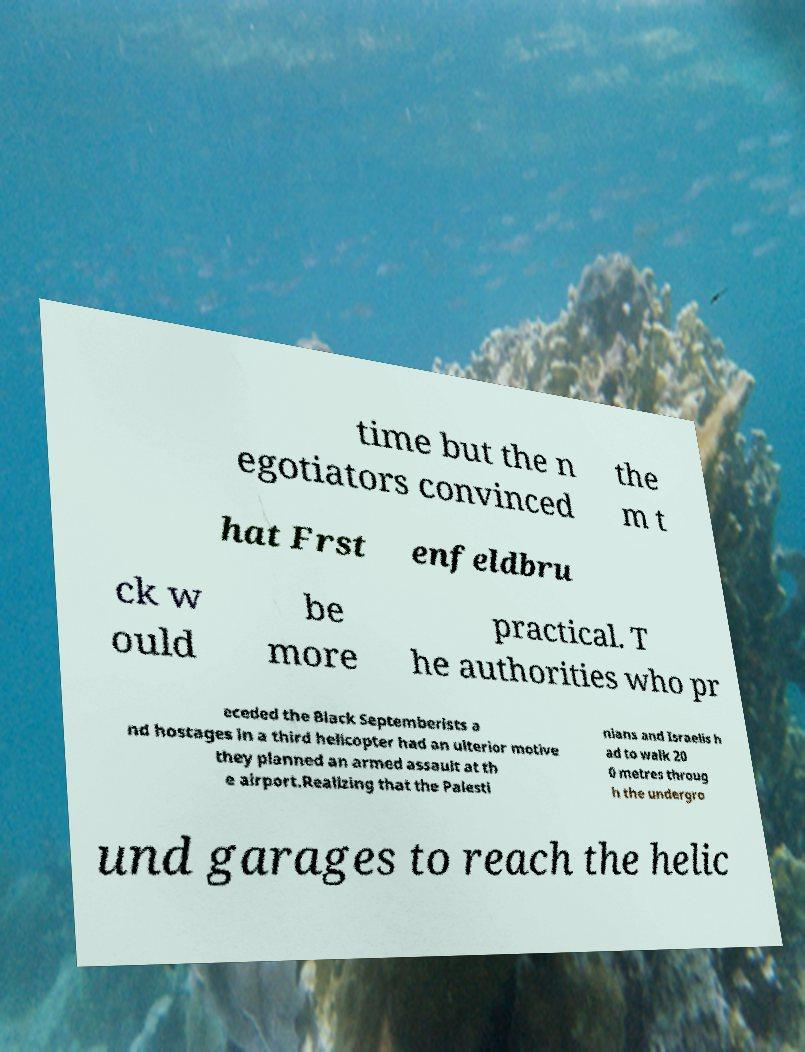I need the written content from this picture converted into text. Can you do that? time but the n egotiators convinced the m t hat Frst enfeldbru ck w ould be more practical. T he authorities who pr eceded the Black Septemberists a nd hostages in a third helicopter had an ulterior motive they planned an armed assault at th e airport.Realizing that the Palesti nians and Israelis h ad to walk 20 0 metres throug h the undergro und garages to reach the helic 